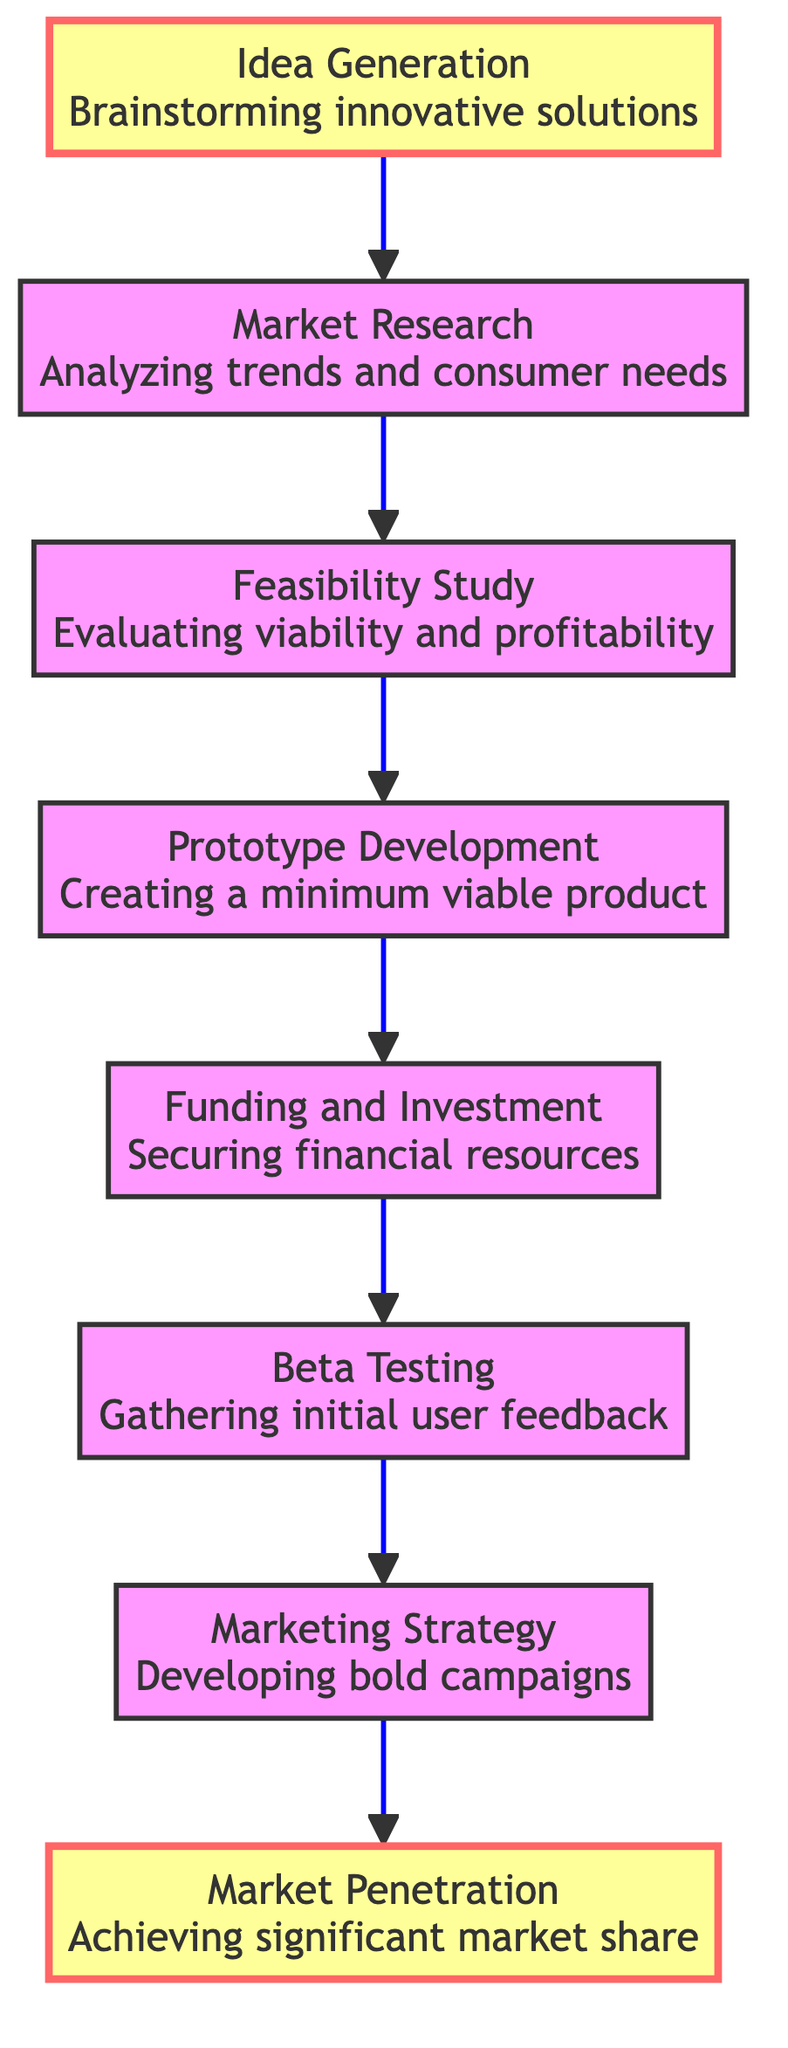What is the first stage in the start-up progression? The first stage listed in the diagram is "Idea Generation." This is indicated as the bottom-most node connected to the next stage, showcasing the initial step in the flow.
Answer: Idea Generation How many total stages are there in the diagram? By counting the distinct stages listed from "Idea Generation" to "Market Penetration," there are a total of eight stages in the flow chart.
Answer: Eight What is the last stage before Market Penetration? The stage immediately prior to "Market Penetration" is "Marketing Strategy." This can be identified as the second to last node in the flow, pointing directly to Market Penetration.
Answer: Marketing Strategy Which stage focuses on securing financial resources? The specific stage that deals with securing financial resources is called "Funding and Investment." This stage is clearly labeled and located just before the "Beta Testing" stage.
Answer: Funding and Investment What stage includes gathering initial user feedback? The stage that involves gathering feedback from initial users is "Beta Testing." This is found in the progression sequence before the "Marketing Strategy" stage.
Answer: Beta Testing Which two stages are highlighted in the diagram? The highlighted stages in the flow chart are "Idea Generation" and "Market Penetration." Their emphasis is noted with a different color fill in the rendered diagram.
Answer: Idea Generation and Market Penetration Which stage involves testing a minimum viable product? The stage that is concerned with creating and testing a minimum viable product is "Prototype Development." It is positioned after the "Feasibility Study" stage.
Answer: Prototype Development What type of feedback is gathered during Beta Testing? During "Beta Testing," the feedback gathered is from initial users. This is indicated in the description of the "Beta Testing" stage.
Answer: Initial user feedback How do the stages progress in this diagram? The stages progress from the bottom to the top, indicating a flow from "Idea Generation" upward to "Market Penetration," showing a clear pathway of development.
Answer: Bottom to top 